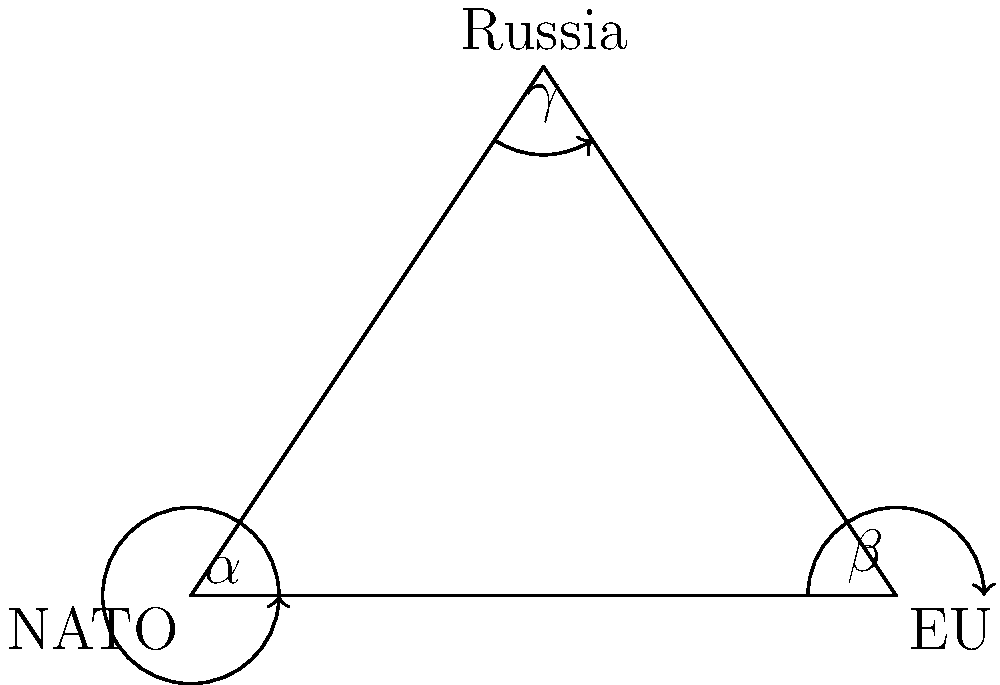In the geopolitical triangle representing NATO, the EU, and Russia, angle $\alpha$ (NATO) measures 53°, and angle $\beta$ (EU) measures 37°. What is the measure of angle $\gamma$ (Russia), and what might this imply about Russia's position in the current geopolitical balance? To solve this problem, we'll follow these steps:

1. Recall the fundamental theorem of triangles: The sum of all angles in a triangle is always 180°.

2. Let $\gamma$ represent the angle for Russia. We can set up the equation:
   $\alpha + \beta + \gamma = 180°$

3. Substitute the known values:
   $53° + 37° + \gamma = 180°$

4. Simplify:
   $90° + \gamma = 180°$

5. Solve for $\gamma$:
   $\gamma = 180° - 90° = 90°$

6. Interpretation: A 90° angle for Russia suggests a pivotal position in this geopolitical triangle. It implies that Russia holds a significant amount of influence, potentially acting as a counterbalance to both NATO and the EU combined. This large angle could represent Russia's ability to play NATO and the EU against each other or its capacity to influence events in both spheres.

7. From a Dutch political analyst's perspective, wary of Russian influences, this geometric representation might be concerning. It suggests that Russia has maintained or even increased its geopolitical weight despite efforts by NATO and the EU to curtail its influence. This could indicate a need for stronger cooperation between NATO and the EU to counterbalance Russian power in the region.
Answer: $90°$; Russia potentially holds a pivotal, influential position between NATO and the EU. 